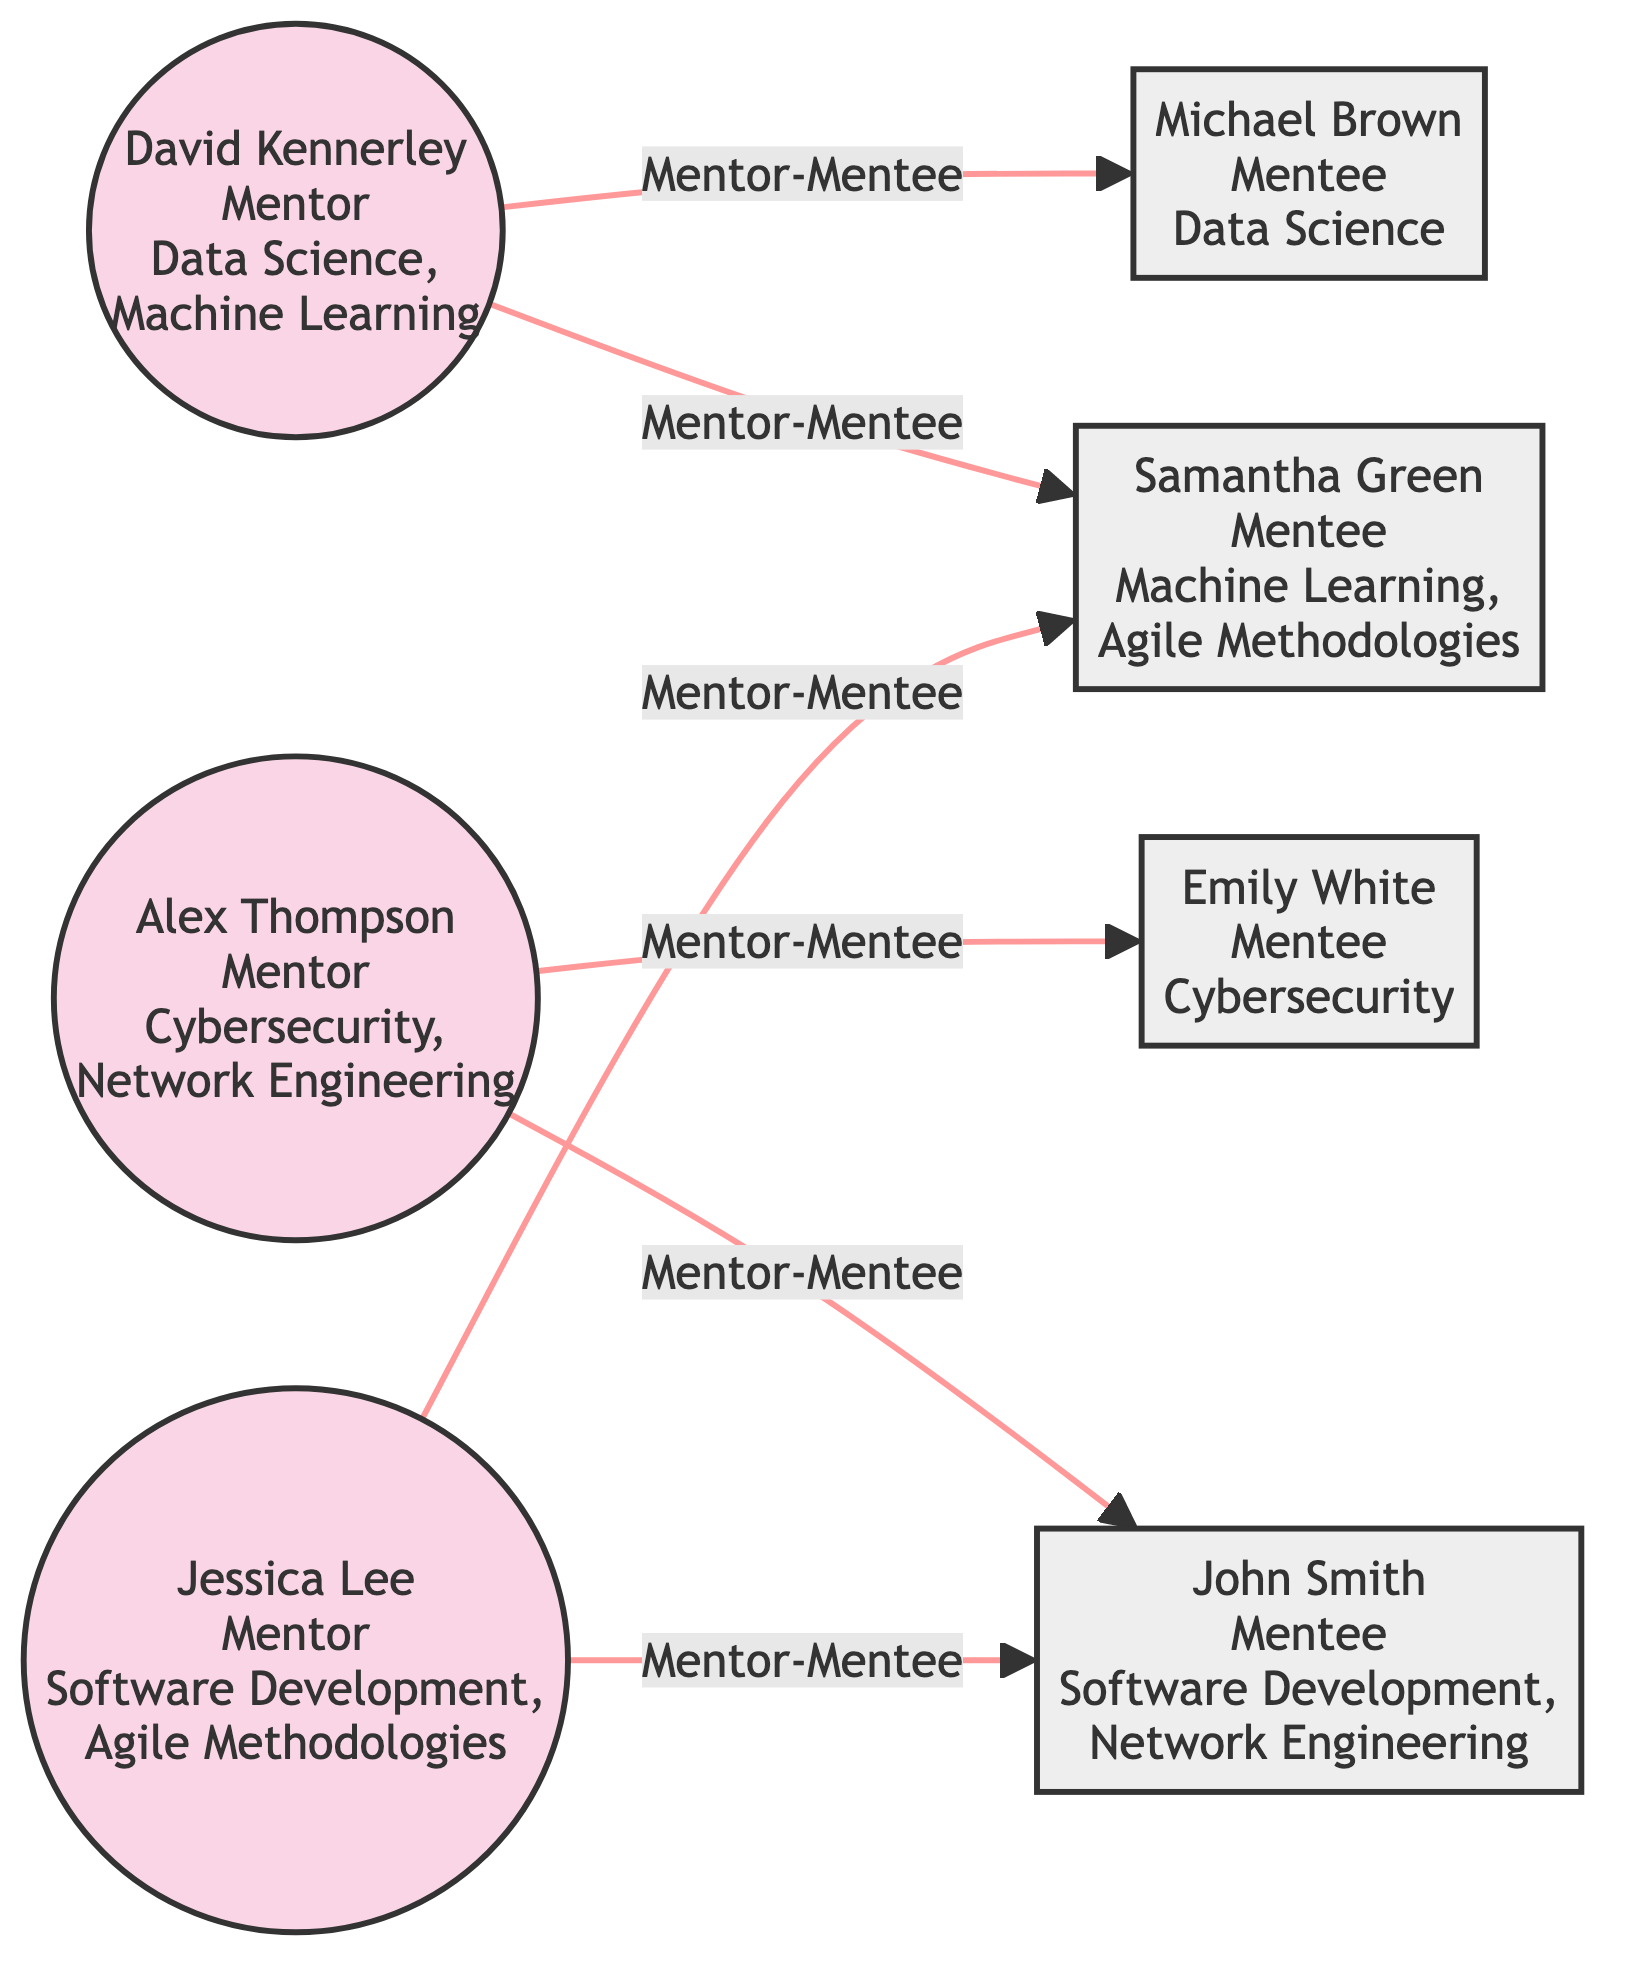What is the total number of mentors in the network? The diagram lists three individuals labeled as mentors: David Kennerley, Alex Thompson, and Jessica Lee. Counting these individuals gives a total of three mentors in the network.
Answer: 3 Who is the mentee assigned to David Kennerley? In the diagram, there are two arrows pointing from David Kennerley to Michael Brown and Samantha Green. Therefore, both individuals are mentees of David Kennerley. Michael Brown is one of them, which answers the question.
Answer: Michael Brown Which mentor specializes in Cybersecurity? The diagram indicates that Alex Thompson is the mentor associated with the area of expertise in Cybersecurity. This can be directly identified from the details provided in his node.
Answer: Alex Thompson How many mentees are assigned to Jessica Lee? The connections show two arrows originating from Jessica Lee which link to Samantha Green and John Smith. Thus, Jessica Lee has two mentees assigned to her.
Answer: 2 What areas of expertise does Samantha Green's assigned mentor have? Samantha Green is connected to two mentors: David Kennerley and Jessica Lee. Looking at their areas of expertise, David Kennerley has expertise in Data Science and Machine Learning, while Jessica Lee specializes in Software Development and Agile Methodologies. Thus, the areas of expertise she has are Data Science, Machine Learning, Software Development, and Agile Methodologies.
Answer: Data Science, Machine Learning, Software Development, Agile Methodologies Which mentee has the most diverse areas of interest? In the diagram, the areas of interest for Michael Brown is Data Science, for Samantha Green are Machine Learning and Agile Methodologies, for Emily White is Cybersecurity, and for John Smith are Software Development and Network Engineering. Samantha Green has two areas of interest, which is the most of any mentee.
Answer: Samantha Green How many connections are there in total in the diagram? Each connection is represented by arrows between the mentors and mentees. By counting these links, we find a total of six connections (or links) between the mentors and their assigned mentees in the diagram.
Answer: 6 Which area of interest does John Smith seek mentorship in? Directly from the diagram, it shows that John Smith is particularly interested in Software Development and Network Engineering. This information comes from his node representation where his areas of interest are listed.
Answer: Software Development, Network Engineering 